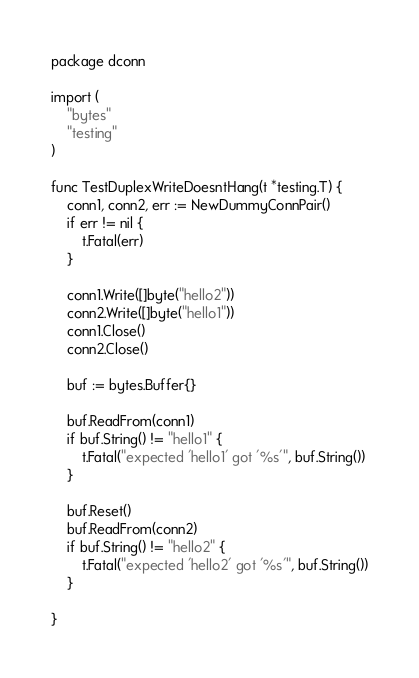Convert code to text. <code><loc_0><loc_0><loc_500><loc_500><_Go_>package dconn

import (
	"bytes"
	"testing"
)

func TestDuplexWriteDoesntHang(t *testing.T) {
	conn1, conn2, err := NewDummyConnPair()
	if err != nil {
		t.Fatal(err)
	}

	conn1.Write([]byte("hello2"))
	conn2.Write([]byte("hello1"))
	conn1.Close()
	conn2.Close()

	buf := bytes.Buffer{}

	buf.ReadFrom(conn1)
	if buf.String() != "hello1" {
		t.Fatal("expected 'hello1' got '%s'", buf.String())
	}

	buf.Reset()
	buf.ReadFrom(conn2)
	if buf.String() != "hello2" {
		t.Fatal("expected 'hello2' got '%s'", buf.String())
	}

}
</code> 